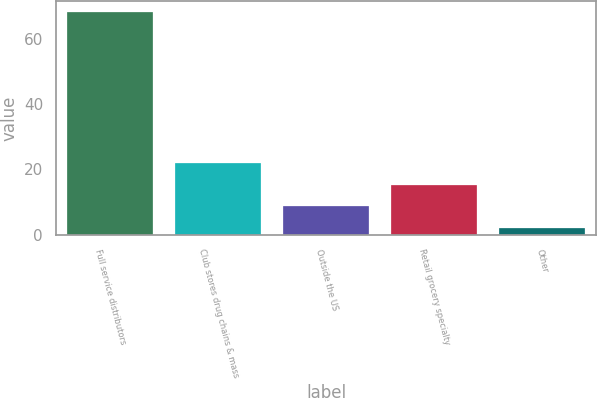Convert chart. <chart><loc_0><loc_0><loc_500><loc_500><bar_chart><fcel>Full service distributors<fcel>Club stores drug chains & mass<fcel>Outside the US<fcel>Retail grocery specialty<fcel>Other<nl><fcel>68<fcel>21.8<fcel>8.6<fcel>15.2<fcel>2<nl></chart> 